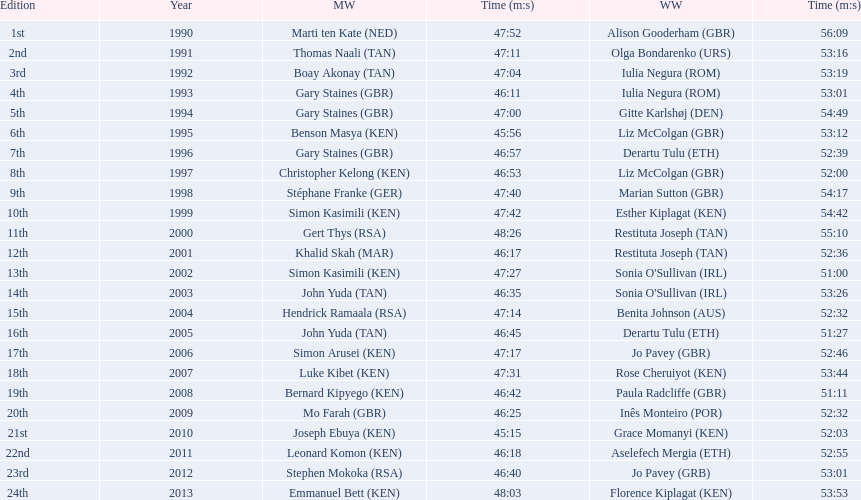What years were the races held? 1990, 1991, 1992, 1993, 1994, 1995, 1996, 1997, 1998, 1999, 2000, 2001, 2002, 2003, 2004, 2005, 2006, 2007, 2008, 2009, 2010, 2011, 2012, 2013. Who was the woman's winner of the 2003 race? Sonia O'Sullivan (IRL). What was her time? 53:26. 